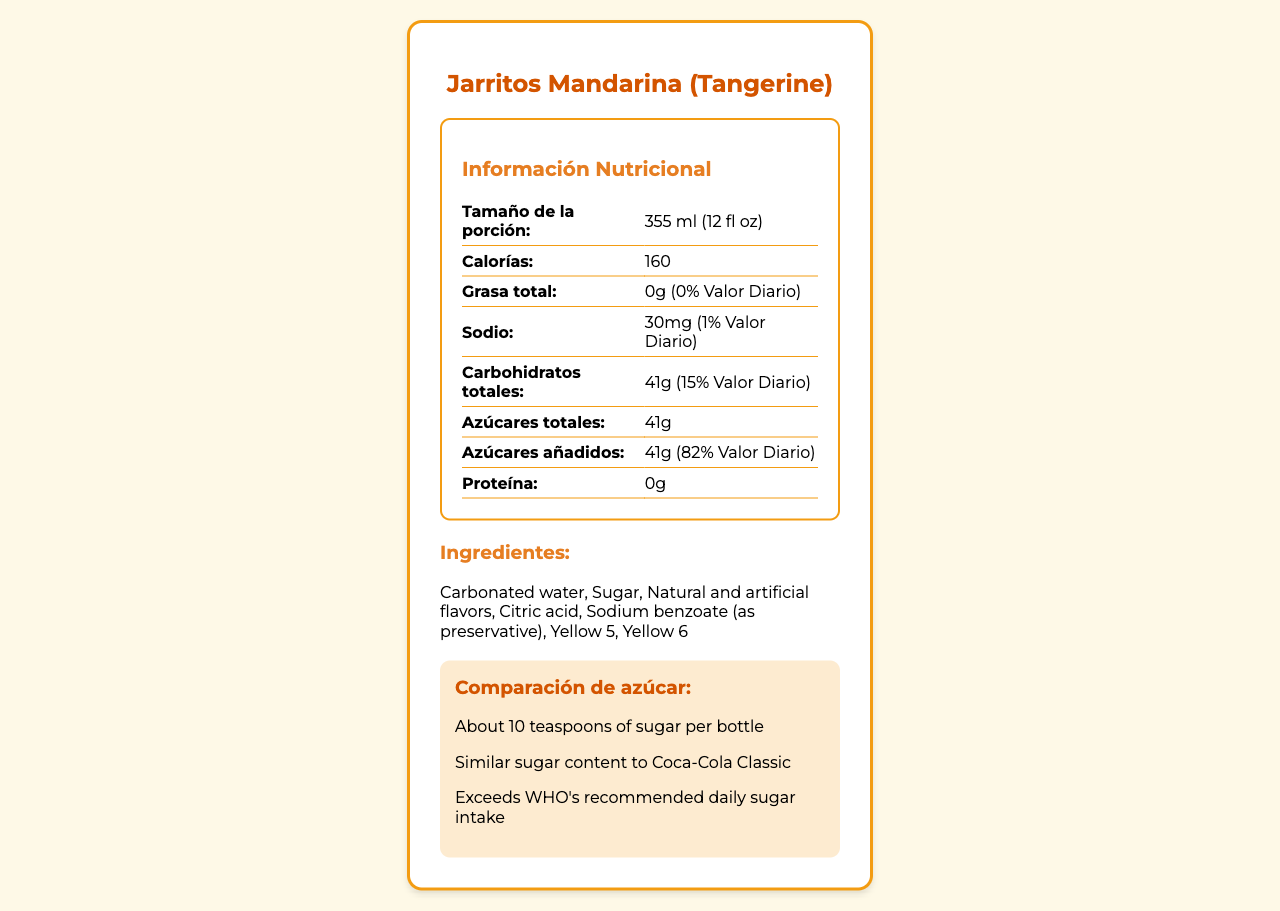what is the total fat content per serving? The document lists the total fat content as "0g" under the "Grasa total" section.
Answer: 0g how much sodium is in one serving of Jarritos Mandarina? The sodium content is labeled as "30mg" in the nutritional information table.
Answer: 30mg how many grams of sugar are in one serving? The "Azúcares totales" section indicates "41g" of sugar per serving.
Answer: 41g what are the main ingredients in Jarritos Mandarina? The main ingredients are listed under the "Ingredientes" section.
Answer: Carbonated water, Sugar, Natural and artificial flavors, Citric acid, Sodium benzoate (as preservative), Yellow 5, Yellow 6 what is the serving size of Jarritos Mandarina? The serving size is stated as "355 ml (12 fl oz)" in the nutritional facts.
Answer: 355 ml (12 fl oz) which nutrient has the highest daily value percentage in one serving? The added sugars have a daily value percentage of 82%, which is higher than any other listed nutrient.
Answer: Added sugars (82%) how many calories are in one serving of Jarritos Mandarina? The number of calories per serving is given as "160" under the "Calorías" section.
Answer: 160 what is the main health concern associated with the sugar content in Jarritos Mandarina? A. Diabetes risk B. Weight gain C. Increased cholesterol levels The document states that the high sugar content may contribute to an increased risk of diabetes.
Answer: A how many teaspoons of sugar are in one bottle of Jarritos Mandarina? A. 5 B. 7 C. 10 The sugar comparison section indicates that there are about 10 teaspoons of sugar per bottle.
Answer: C does Jarritos Mandarina contain any protein? The document lists the protein content as "0g".
Answer: No is the sugar content of Jarritos Mandarina similar to that of Coca-Cola Classic? The comparison section notes that Jarritos Mandarina has a similar sugar content to Coca-Cola Classic.
Answer: Yes can we determine which Mexican states prefer Jarritos Mandarina based on the document? The regional variation section indicates that Jarritos Mandarina is more popular in Northern states.
Answer: Yes does Jarritos Mandarina provide any vitamin C? The vitamin C content is listed as "0mg" in the nutritional information.
Answer: No summarize the nutritional information presented in the document for Jarritos Mandarina. The document provides details about the nutrient contents, stating that there is no total fat or protein present, while the sodium content is minimal at 30mg. Carbohydrates and sugars are significant, amounting to 41g each, and the serving size is 355 ml with 160 calories.
Answer: Jarritos Mandarina has zero total fat and protein, 30mg of sodium, 41g of total carbohydrates, and 41g of total sugars which are entirely added sugars. The serving size is 355 ml and contains 160 calories. what is the contribution of calcium from Jarritos Mandarina? The document does not specify calcium contribution in enough detail to determine the percentage daily value.
Answer: Not enough information 